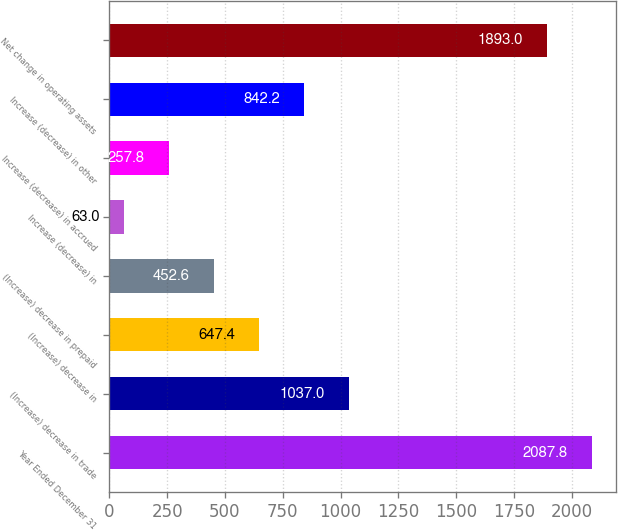<chart> <loc_0><loc_0><loc_500><loc_500><bar_chart><fcel>Year Ended December 31<fcel>(Increase) decrease in trade<fcel>(Increase) decrease in<fcel>(Increase) decrease in prepaid<fcel>Increase (decrease) in<fcel>Increase (decrease) in accrued<fcel>Increase (decrease) in other<fcel>Net change in operating assets<nl><fcel>2087.8<fcel>1037<fcel>647.4<fcel>452.6<fcel>63<fcel>257.8<fcel>842.2<fcel>1893<nl></chart> 